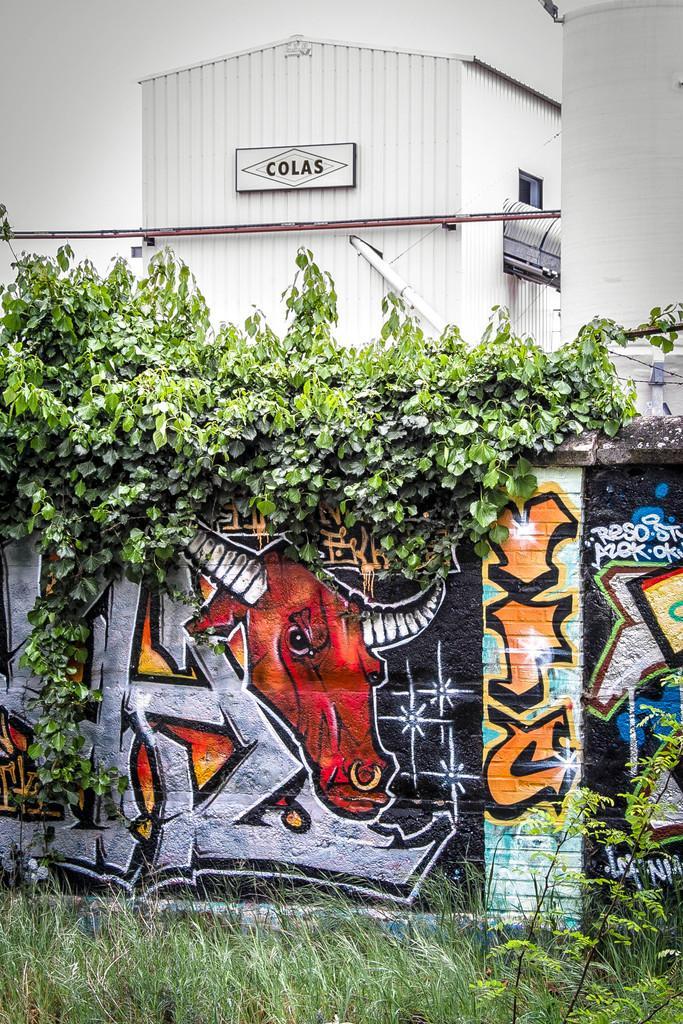Please provide a concise description of this image. In this picture we can see the grass and a wall with a painting on it and in the background we can see plants, shed. 